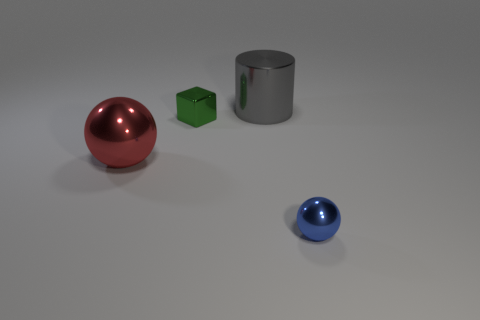Add 1 large red metallic balls. How many objects exist? 5 Subtract all cylinders. How many objects are left? 3 Add 1 gray balls. How many gray balls exist? 1 Subtract 1 gray cylinders. How many objects are left? 3 Subtract all small blocks. Subtract all big red metal balls. How many objects are left? 2 Add 4 large things. How many large things are left? 6 